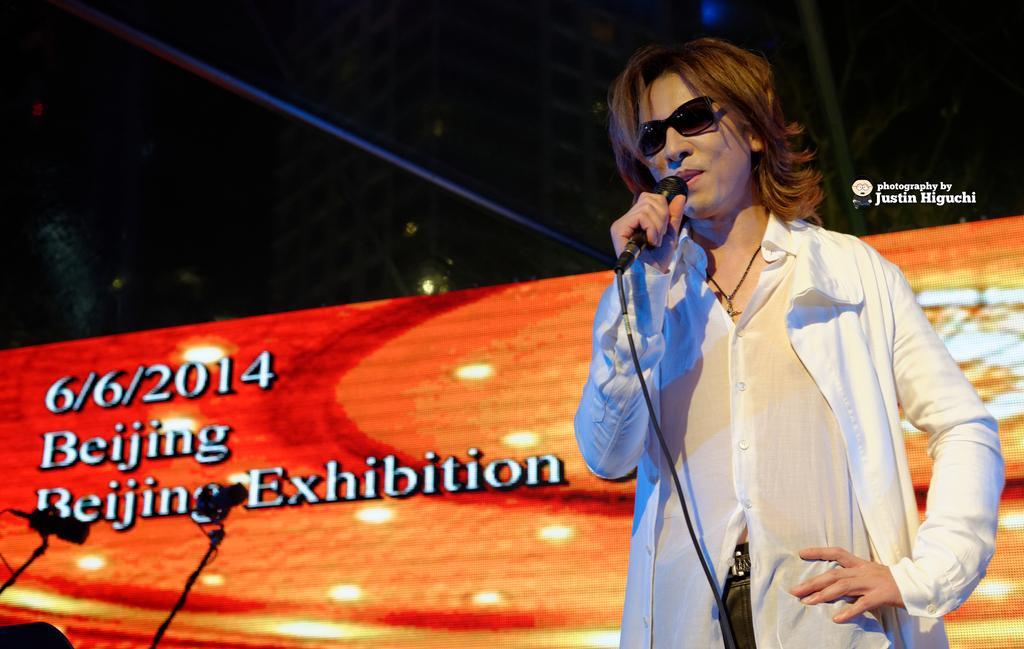Describe this image in one or two sentences. On the right side of the image there is a person holding the mike. Behind him there is a banner. On the left side of the image there are two cameras. In the background of the image there is a light. There is some text on the right side of the image. 